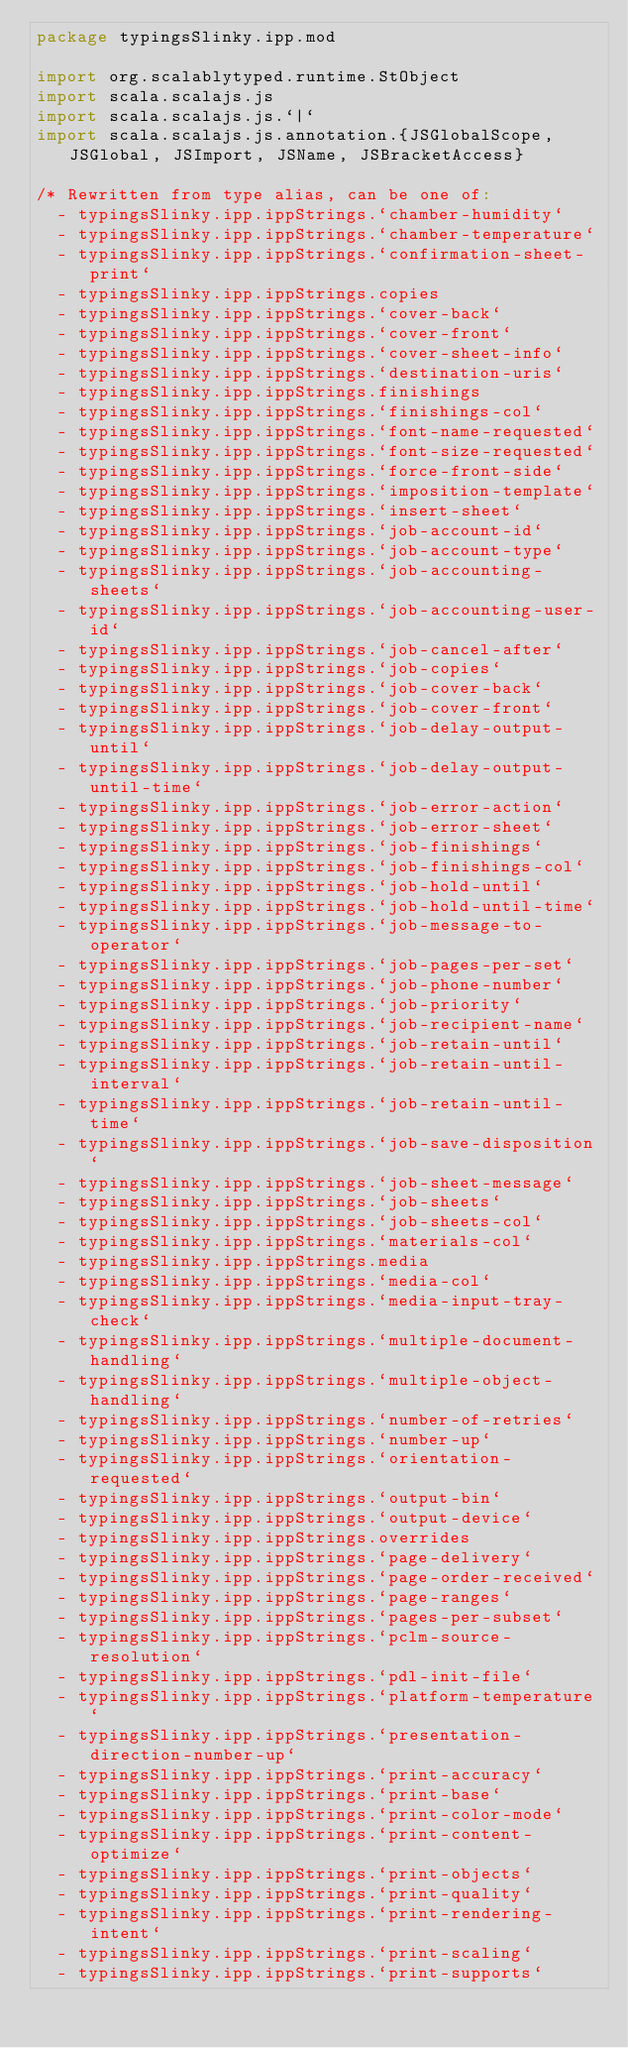Convert code to text. <code><loc_0><loc_0><loc_500><loc_500><_Scala_>package typingsSlinky.ipp.mod

import org.scalablytyped.runtime.StObject
import scala.scalajs.js
import scala.scalajs.js.`|`
import scala.scalajs.js.annotation.{JSGlobalScope, JSGlobal, JSImport, JSName, JSBracketAccess}

/* Rewritten from type alias, can be one of: 
  - typingsSlinky.ipp.ippStrings.`chamber-humidity`
  - typingsSlinky.ipp.ippStrings.`chamber-temperature`
  - typingsSlinky.ipp.ippStrings.`confirmation-sheet-print`
  - typingsSlinky.ipp.ippStrings.copies
  - typingsSlinky.ipp.ippStrings.`cover-back`
  - typingsSlinky.ipp.ippStrings.`cover-front`
  - typingsSlinky.ipp.ippStrings.`cover-sheet-info`
  - typingsSlinky.ipp.ippStrings.`destination-uris`
  - typingsSlinky.ipp.ippStrings.finishings
  - typingsSlinky.ipp.ippStrings.`finishings-col`
  - typingsSlinky.ipp.ippStrings.`font-name-requested`
  - typingsSlinky.ipp.ippStrings.`font-size-requested`
  - typingsSlinky.ipp.ippStrings.`force-front-side`
  - typingsSlinky.ipp.ippStrings.`imposition-template`
  - typingsSlinky.ipp.ippStrings.`insert-sheet`
  - typingsSlinky.ipp.ippStrings.`job-account-id`
  - typingsSlinky.ipp.ippStrings.`job-account-type`
  - typingsSlinky.ipp.ippStrings.`job-accounting-sheets`
  - typingsSlinky.ipp.ippStrings.`job-accounting-user-id`
  - typingsSlinky.ipp.ippStrings.`job-cancel-after`
  - typingsSlinky.ipp.ippStrings.`job-copies`
  - typingsSlinky.ipp.ippStrings.`job-cover-back`
  - typingsSlinky.ipp.ippStrings.`job-cover-front`
  - typingsSlinky.ipp.ippStrings.`job-delay-output-until`
  - typingsSlinky.ipp.ippStrings.`job-delay-output-until-time`
  - typingsSlinky.ipp.ippStrings.`job-error-action`
  - typingsSlinky.ipp.ippStrings.`job-error-sheet`
  - typingsSlinky.ipp.ippStrings.`job-finishings`
  - typingsSlinky.ipp.ippStrings.`job-finishings-col`
  - typingsSlinky.ipp.ippStrings.`job-hold-until`
  - typingsSlinky.ipp.ippStrings.`job-hold-until-time`
  - typingsSlinky.ipp.ippStrings.`job-message-to-operator`
  - typingsSlinky.ipp.ippStrings.`job-pages-per-set`
  - typingsSlinky.ipp.ippStrings.`job-phone-number`
  - typingsSlinky.ipp.ippStrings.`job-priority`
  - typingsSlinky.ipp.ippStrings.`job-recipient-name`
  - typingsSlinky.ipp.ippStrings.`job-retain-until`
  - typingsSlinky.ipp.ippStrings.`job-retain-until-interval`
  - typingsSlinky.ipp.ippStrings.`job-retain-until-time`
  - typingsSlinky.ipp.ippStrings.`job-save-disposition`
  - typingsSlinky.ipp.ippStrings.`job-sheet-message`
  - typingsSlinky.ipp.ippStrings.`job-sheets`
  - typingsSlinky.ipp.ippStrings.`job-sheets-col`
  - typingsSlinky.ipp.ippStrings.`materials-col`
  - typingsSlinky.ipp.ippStrings.media
  - typingsSlinky.ipp.ippStrings.`media-col`
  - typingsSlinky.ipp.ippStrings.`media-input-tray-check`
  - typingsSlinky.ipp.ippStrings.`multiple-document-handling`
  - typingsSlinky.ipp.ippStrings.`multiple-object-handling`
  - typingsSlinky.ipp.ippStrings.`number-of-retries`
  - typingsSlinky.ipp.ippStrings.`number-up`
  - typingsSlinky.ipp.ippStrings.`orientation-requested`
  - typingsSlinky.ipp.ippStrings.`output-bin`
  - typingsSlinky.ipp.ippStrings.`output-device`
  - typingsSlinky.ipp.ippStrings.overrides
  - typingsSlinky.ipp.ippStrings.`page-delivery`
  - typingsSlinky.ipp.ippStrings.`page-order-received`
  - typingsSlinky.ipp.ippStrings.`page-ranges`
  - typingsSlinky.ipp.ippStrings.`pages-per-subset`
  - typingsSlinky.ipp.ippStrings.`pclm-source-resolution`
  - typingsSlinky.ipp.ippStrings.`pdl-init-file`
  - typingsSlinky.ipp.ippStrings.`platform-temperature`
  - typingsSlinky.ipp.ippStrings.`presentation-direction-number-up`
  - typingsSlinky.ipp.ippStrings.`print-accuracy`
  - typingsSlinky.ipp.ippStrings.`print-base`
  - typingsSlinky.ipp.ippStrings.`print-color-mode`
  - typingsSlinky.ipp.ippStrings.`print-content-optimize`
  - typingsSlinky.ipp.ippStrings.`print-objects`
  - typingsSlinky.ipp.ippStrings.`print-quality`
  - typingsSlinky.ipp.ippStrings.`print-rendering-intent`
  - typingsSlinky.ipp.ippStrings.`print-scaling`
  - typingsSlinky.ipp.ippStrings.`print-supports`</code> 